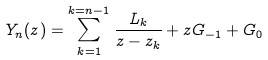Convert formula to latex. <formula><loc_0><loc_0><loc_500><loc_500>Y _ { n } ( z ) = \sum _ { k = 1 } ^ { k = n - 1 } \frac { L _ { k } } { z - z _ { k } } + z G _ { - 1 } + G _ { 0 }</formula> 